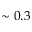Convert formula to latex. <formula><loc_0><loc_0><loc_500><loc_500>\sim 0 . 3</formula> 